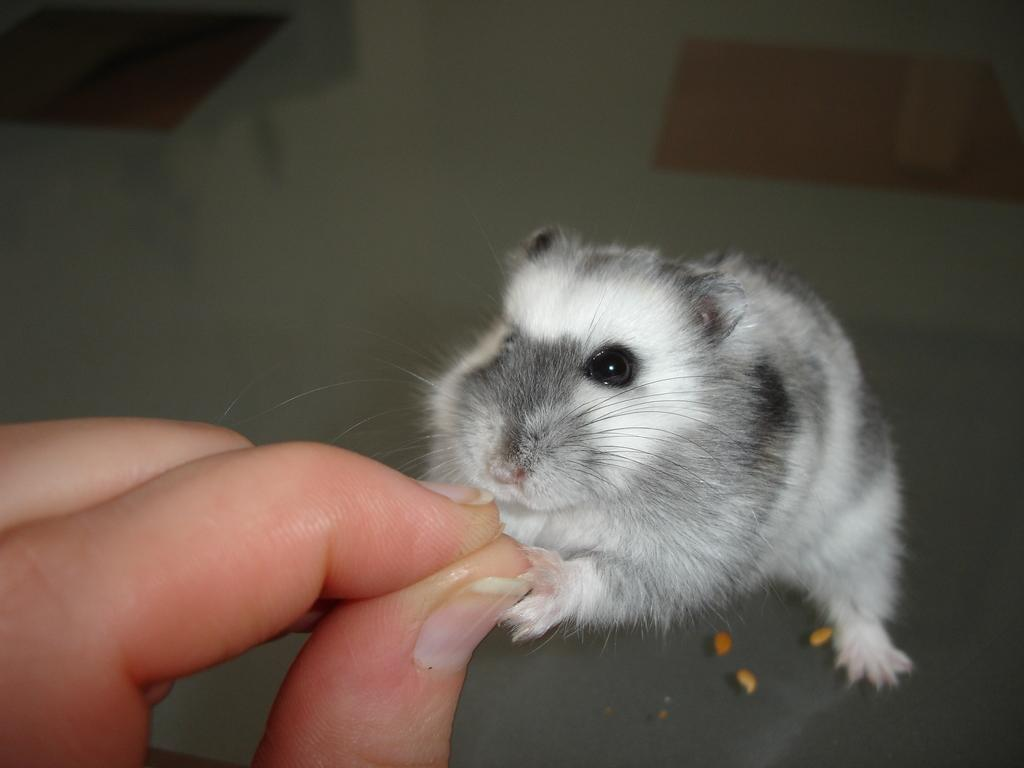What part of a person is visible in the image? There are fingers of a person in the image. What else can be seen in the image besides the person's fingers? There is an animal on a surface in the image. What type of cakes are being exchanged between the toad and the person in the image? There is no toad or exchange of cakes present in the image. 